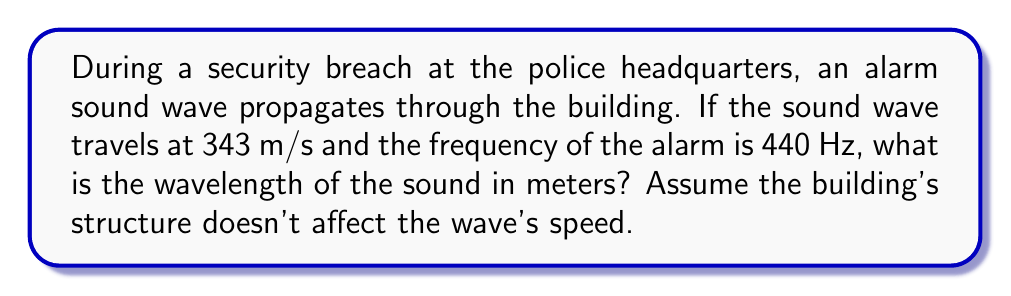Provide a solution to this math problem. Let's approach this step-by-step:

1) The relationship between wave speed ($v$), frequency ($f$), and wavelength ($\lambda$) is given by the wave equation:

   $$v = f \lambda$$

2) We are given:
   - Wave speed ($v$) = 343 m/s (speed of sound in air)
   - Frequency ($f$) = 440 Hz

3) We need to solve for wavelength ($\lambda$). Let's rearrange the equation:

   $$\lambda = \frac{v}{f}$$

4) Now, let's substitute our known values:

   $$\lambda = \frac{343 \text{ m/s}}{440 \text{ Hz}}$$

5) Simplify:
   
   $$\lambda = 0.77954545... \text{ m}$$

6) Rounding to two decimal places:

   $$\lambda \approx 0.78 \text{ m}$$

This means that during the security breach, the alarm sound waves traveling through the building have a wavelength of approximately 0.78 meters.
Answer: $0.78 \text{ m}$ 